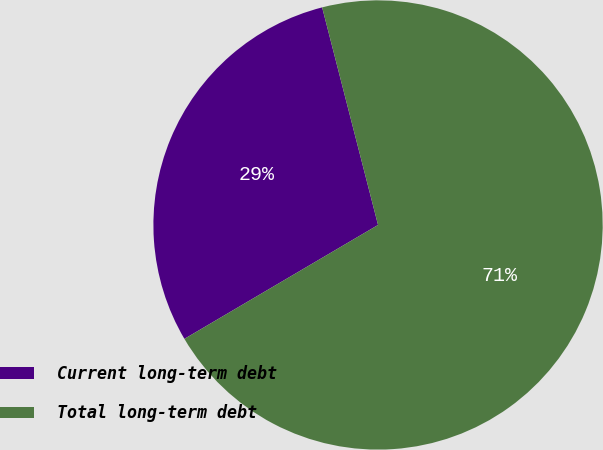Convert chart to OTSL. <chart><loc_0><loc_0><loc_500><loc_500><pie_chart><fcel>Current long-term debt<fcel>Total long-term debt<nl><fcel>29.46%<fcel>70.54%<nl></chart> 